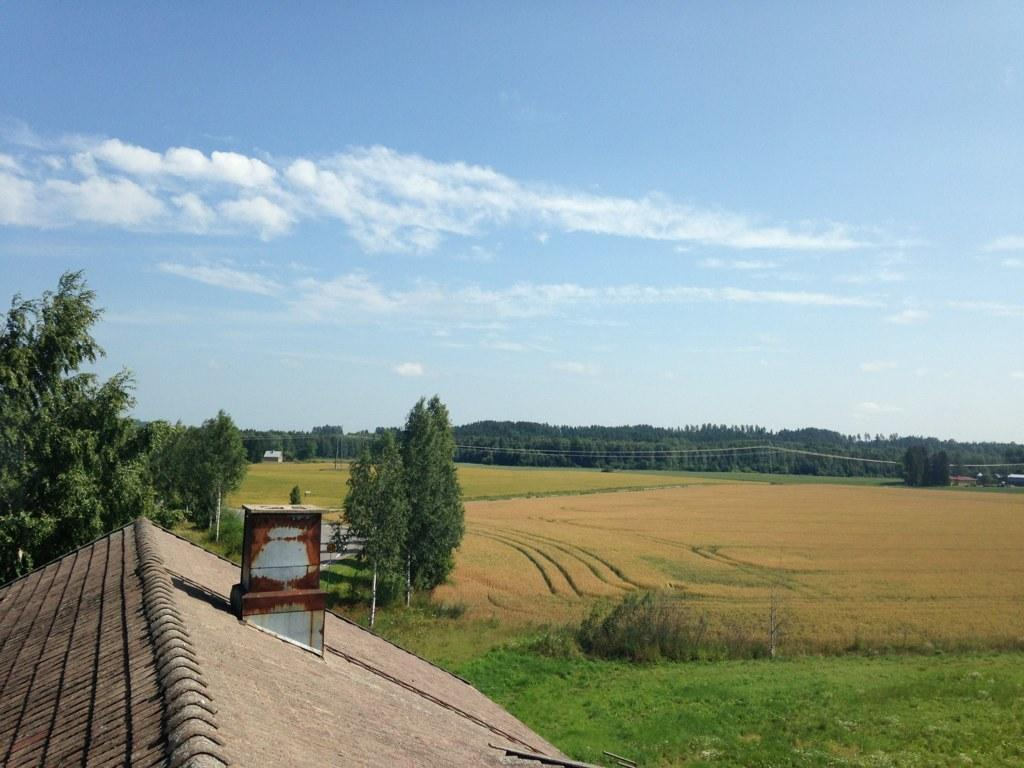What structure is located on the left side of the image? There is a roof on the left side of the image. What type of vegetation is behind the roof? There are trees behind the roof. What type of vegetation is on the right side of the image? There is grass on the right side of the image. What else can be seen in the image besides the roof and vegetation? There are wires visible in the image. What is visible at the back of the image? There are trees at the back of the image. What is visible at the top of the image? The sky is visible at the top of the image. Where is the knife located in the image? There is no knife present in the image. What type of tub is visible in the image? There is no tub present in the image. 